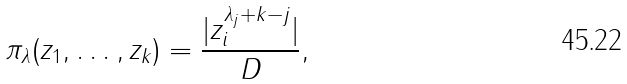Convert formula to latex. <formula><loc_0><loc_0><loc_500><loc_500>\pi _ { \lambda } ( z _ { 1 } , \dots , z _ { k } ) = \frac { | z _ { i } ^ { \lambda _ { j } + k - j } | } { D } ,</formula> 